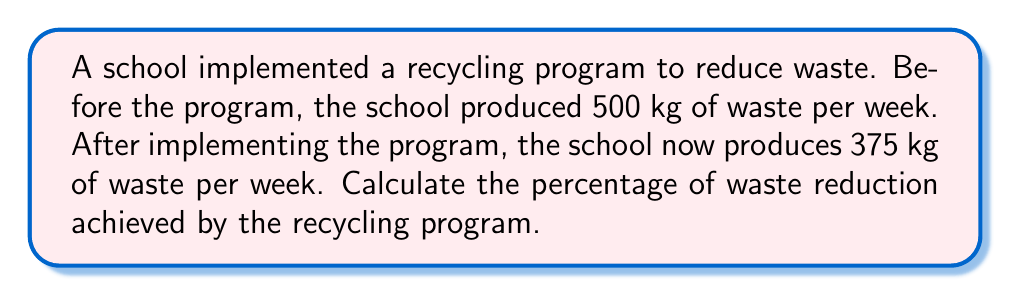Provide a solution to this math problem. To calculate the percentage of waste reduction, we need to follow these steps:

1. Calculate the amount of waste reduced:
   $\text{Waste reduced} = \text{Initial waste} - \text{Final waste}$
   $\text{Waste reduced} = 500 \text{ kg} - 375 \text{ kg} = 125 \text{ kg}$

2. Calculate the percentage of waste reduction:
   $$\text{Percentage reduction} = \frac{\text{Waste reduced}}{\text{Initial waste}} \times 100\%$$
   
   $$\text{Percentage reduction} = \frac{125 \text{ kg}}{500 \text{ kg}} \times 100\%$$
   
   $$\text{Percentage reduction} = 0.25 \times 100\% = 25\%$$

Therefore, the recycling program achieved a 25% reduction in waste.
Answer: 25% 